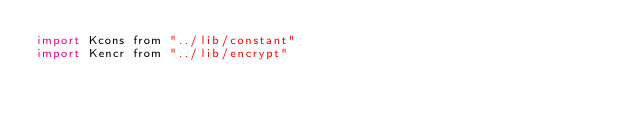Convert code to text. <code><loc_0><loc_0><loc_500><loc_500><_JavaScript_>import Kcons from "../lib/constant"
import Kencr from "../lib/encrypt"</code> 